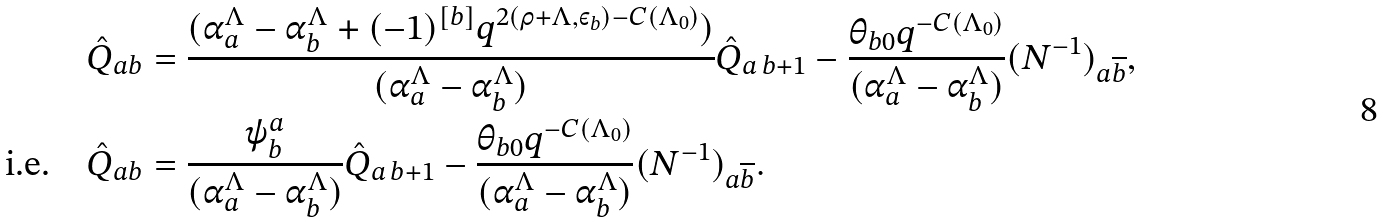Convert formula to latex. <formula><loc_0><loc_0><loc_500><loc_500>& \hat { Q } _ { a b } = \frac { ( \alpha _ { a } ^ { \Lambda } - \alpha _ { b } ^ { \Lambda } + ( - 1 ) ^ { [ b ] } q ^ { 2 ( \rho + \Lambda , \varepsilon _ { b } ) - C ( \Lambda _ { 0 } ) } ) } { ( \alpha _ { a } ^ { \Lambda } - \alpha _ { b } ^ { \Lambda } ) } \hat { Q } _ { a \, b + 1 } - \frac { \theta _ { b 0 } q ^ { - C ( \Lambda _ { 0 } ) } } { ( \alpha _ { a } ^ { \Lambda } - \alpha _ { b } ^ { \Lambda } ) } ( N ^ { - 1 } ) _ { a \overline { b } } , \\ \text {i.e.} \quad & \hat { Q } _ { a b } = \frac { \psi ^ { a } _ { b } } { ( \alpha _ { a } ^ { \Lambda } - \alpha _ { b } ^ { \Lambda } ) } \hat { Q } _ { a \, b + 1 } - \frac { \theta _ { b 0 } q ^ { - C ( \Lambda _ { 0 } ) } } { ( \alpha _ { a } ^ { \Lambda } - \alpha _ { b } ^ { \Lambda } ) } ( N ^ { - 1 } ) _ { a \overline { b } } .</formula> 